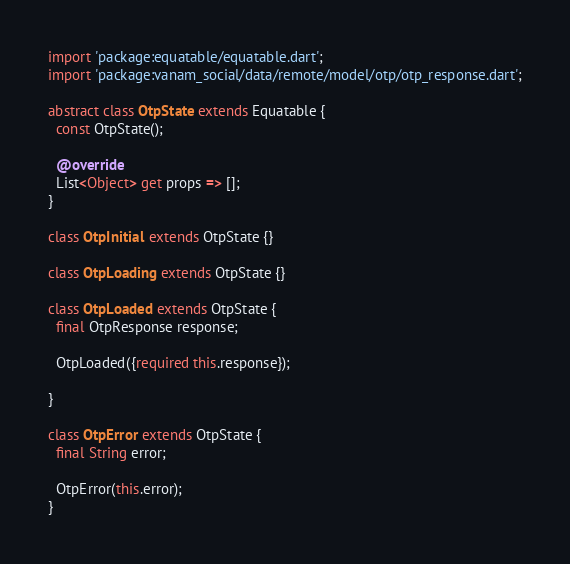<code> <loc_0><loc_0><loc_500><loc_500><_Dart_>import 'package:equatable/equatable.dart';
import 'package:vanam_social/data/remote/model/otp/otp_response.dart';

abstract class OtpState extends Equatable {
  const OtpState();

  @override
  List<Object> get props => [];
}

class OtpInitial extends OtpState {}

class OtpLoading extends OtpState {}

class OtpLoaded extends OtpState {
  final OtpResponse response;

  OtpLoaded({required this.response});

}

class OtpError extends OtpState {
  final String error;

  OtpError(this.error);
}</code> 